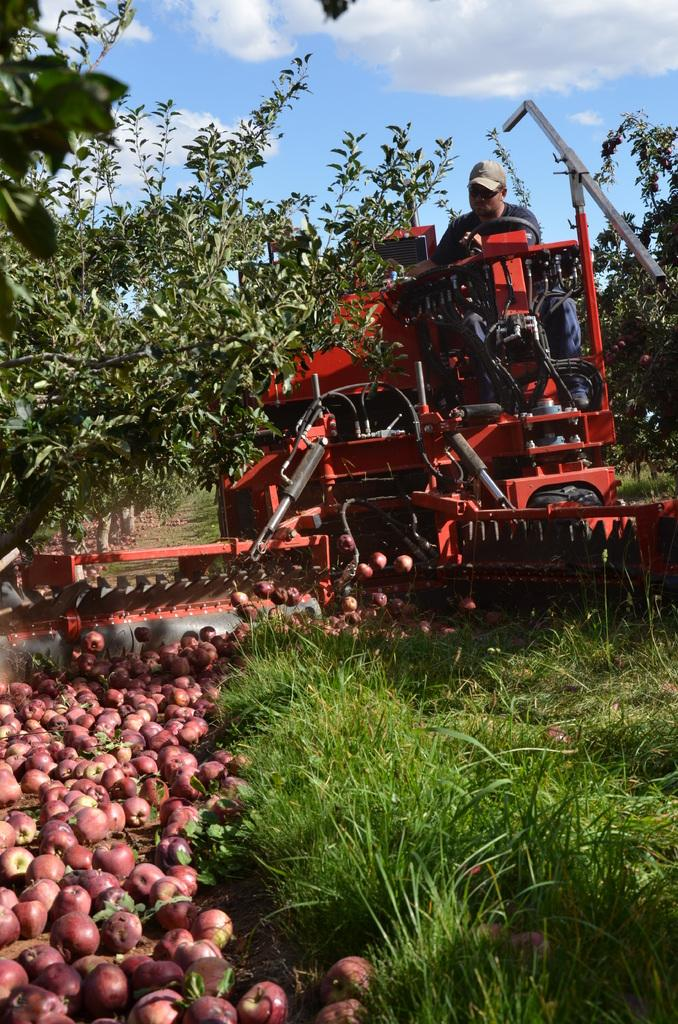What type of fruit can be seen in the image? There are apples in the image. What else is present in the image besides the apples? There is a vehicle, a person, plants, and trees in the image. Can you describe the weather condition in the image? The sky is cloudy in the image. What type of spot can be seen on the person's teeth in the image? There is no person's teeth visible in the image, so it is not possible to determine if there is a spot on them. --- 